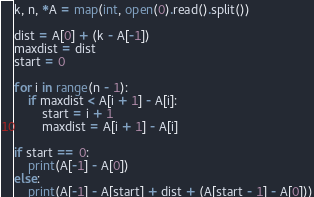Convert code to text. <code><loc_0><loc_0><loc_500><loc_500><_Python_>k, n, *A = map(int, open(0).read().split())

dist = A[0] + (k - A[-1])
maxdist = dist
start = 0

for i in range(n - 1):
    if maxdist < A[i + 1] - A[i]:
        start = i + 1
        maxdist = A[i + 1] - A[i]

if start == 0:
    print(A[-1] - A[0])
else:
    print(A[-1] - A[start] + dist + (A[start - 1] - A[0]))</code> 